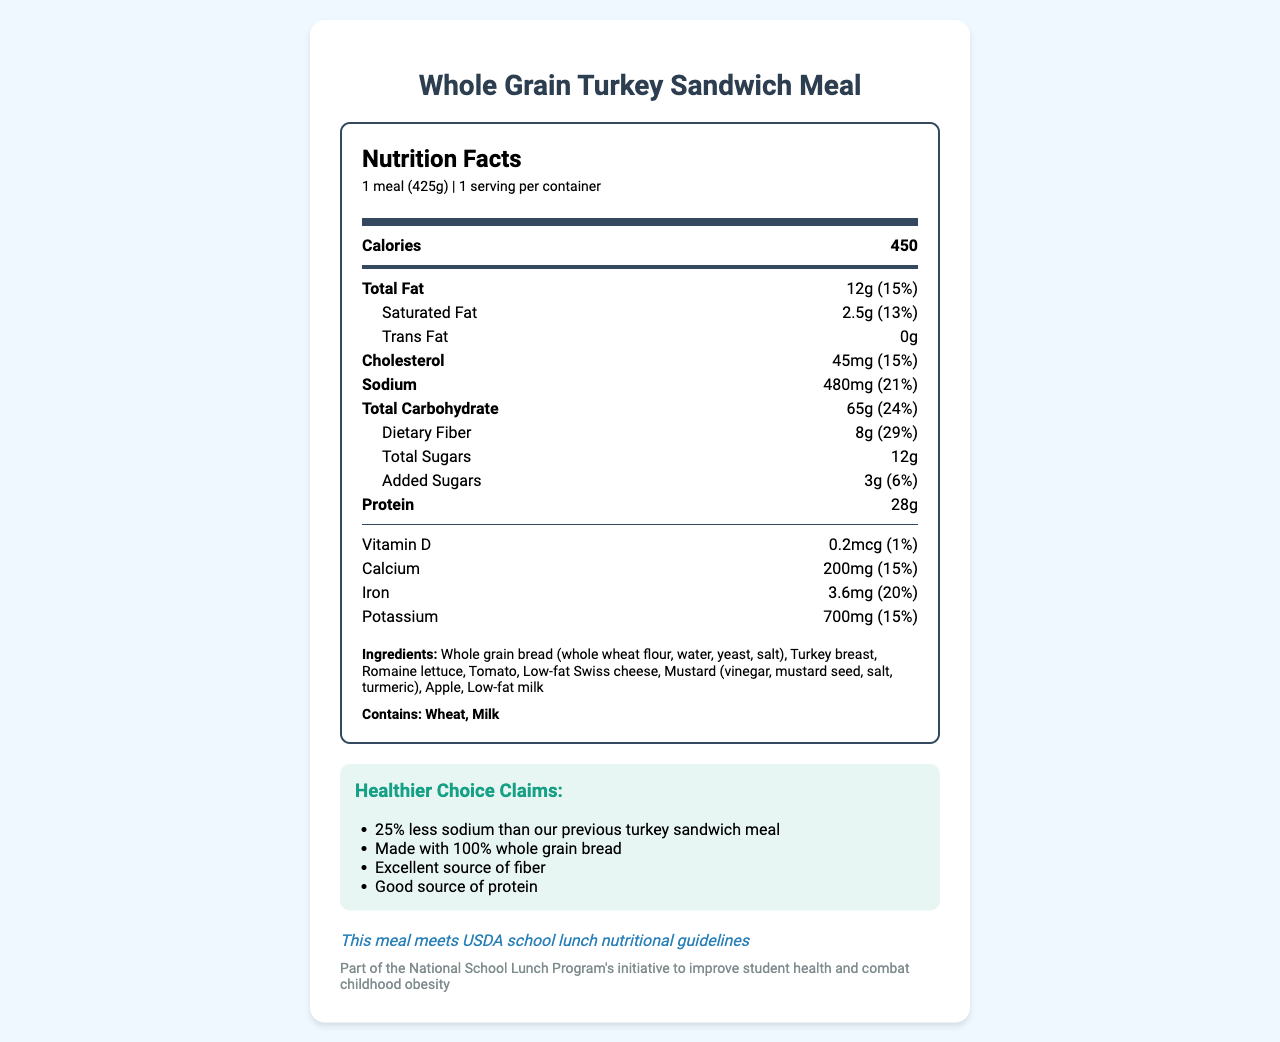what is the total fat content per serving? The document specifies that the total fat content for one serving of the Whole Grain Turkey Sandwich Meal is 12g.
Answer: 12g how much sodium is in one serving of the meal? According to the nutrition facts, one serving contains 480mg of sodium.
Answer: 480mg how many grams of dietary fiber does the meal contain? The nutrition label states that each serving has 8g of dietary fiber.
Answer: 8g what are the main ingredients in the Whole Grain Turkey Sandwich Meal? The ingredient list includes these main components.
Answer: Whole grain bread, turkey breast, romaine lettuce, tomato, low-fat Swiss cheese, mustard, apple, low-fat milk how many calories are there per serving? The nutrition label indicates that there are 450 calories in one serving of the meal.
Answer: 450 what is the percent daily value for iron in this meal? The document states that the percent daily value of iron is 20%.
Answer: 20% what allergens are contained in this meal? The document lists wheat and milk as allergens present in the meal.
Answer: Wheat, Milk which vitamin has the lowest percent daily value? The nutrition label shows vitamin D with a percent daily value of 1%.
Answer: Vitamin D which of the following is a healthier choice claim made for this meal? A. 50% less sodium B. Made with 100% whole grain bread C. Excellent source of protein The meal claims to be made with 100% whole grain bread as one of its healthier choice aspects.
Answer: B. Made with 100% whole grain bread what is the serving size of the Whole Grain Turkey Sandwich Meal? A. 1 meal (300g) B. 1 meal (425g) C. 1 sandwich (425g) The serving size is listed as 1 meal (425g).
Answer: B. 1 meal (425g) is this meal endorsed by any government body? The document states that the meal meets USDA school lunch nutritional guidelines, indicating government endorsement.
Answer: Yes summarize the main idea of the document. The document includes detailed nutrition information, ingredients, allergen warnings, healthier choice claims, and confirms that the meal meets USDA guidelines as part of a national initiative to improve student health.
Answer: This document describes the nutrition facts for a proposed healthier school lunch, the Whole Grain Turkey Sandwich Meal, emphasizing its reduced sodium and increased whole grains. what is the source of the protein in the meal? The document lists the total protein amount but does not specify all the sources of the protein explicitly.
Answer: Not enough information 